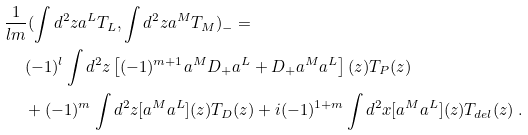Convert formula to latex. <formula><loc_0><loc_0><loc_500><loc_500>& \frac { 1 } { l m } ( \int d ^ { 2 } z a ^ { L } T _ { L } , \int d ^ { 2 } z a ^ { M } T _ { M } ) _ { - } = \\ & \quad \ ( - 1 ) ^ { l } \int d ^ { 2 } z \left [ ( - 1 ) ^ { m + 1 } a ^ { M } D _ { + } a ^ { L } + D _ { + } a ^ { M } a ^ { L } \right ] ( z ) T _ { P } ( z ) \\ & \quad \ + ( - 1 ) ^ { m } \int d ^ { 2 } z [ a ^ { M } a ^ { L } ] ( z ) T _ { D } ( z ) + i ( - 1 ) ^ { 1 + m } \int d ^ { 2 } x [ a ^ { M } a ^ { L } ] ( z ) T _ { d e l } ( z ) \ .</formula> 